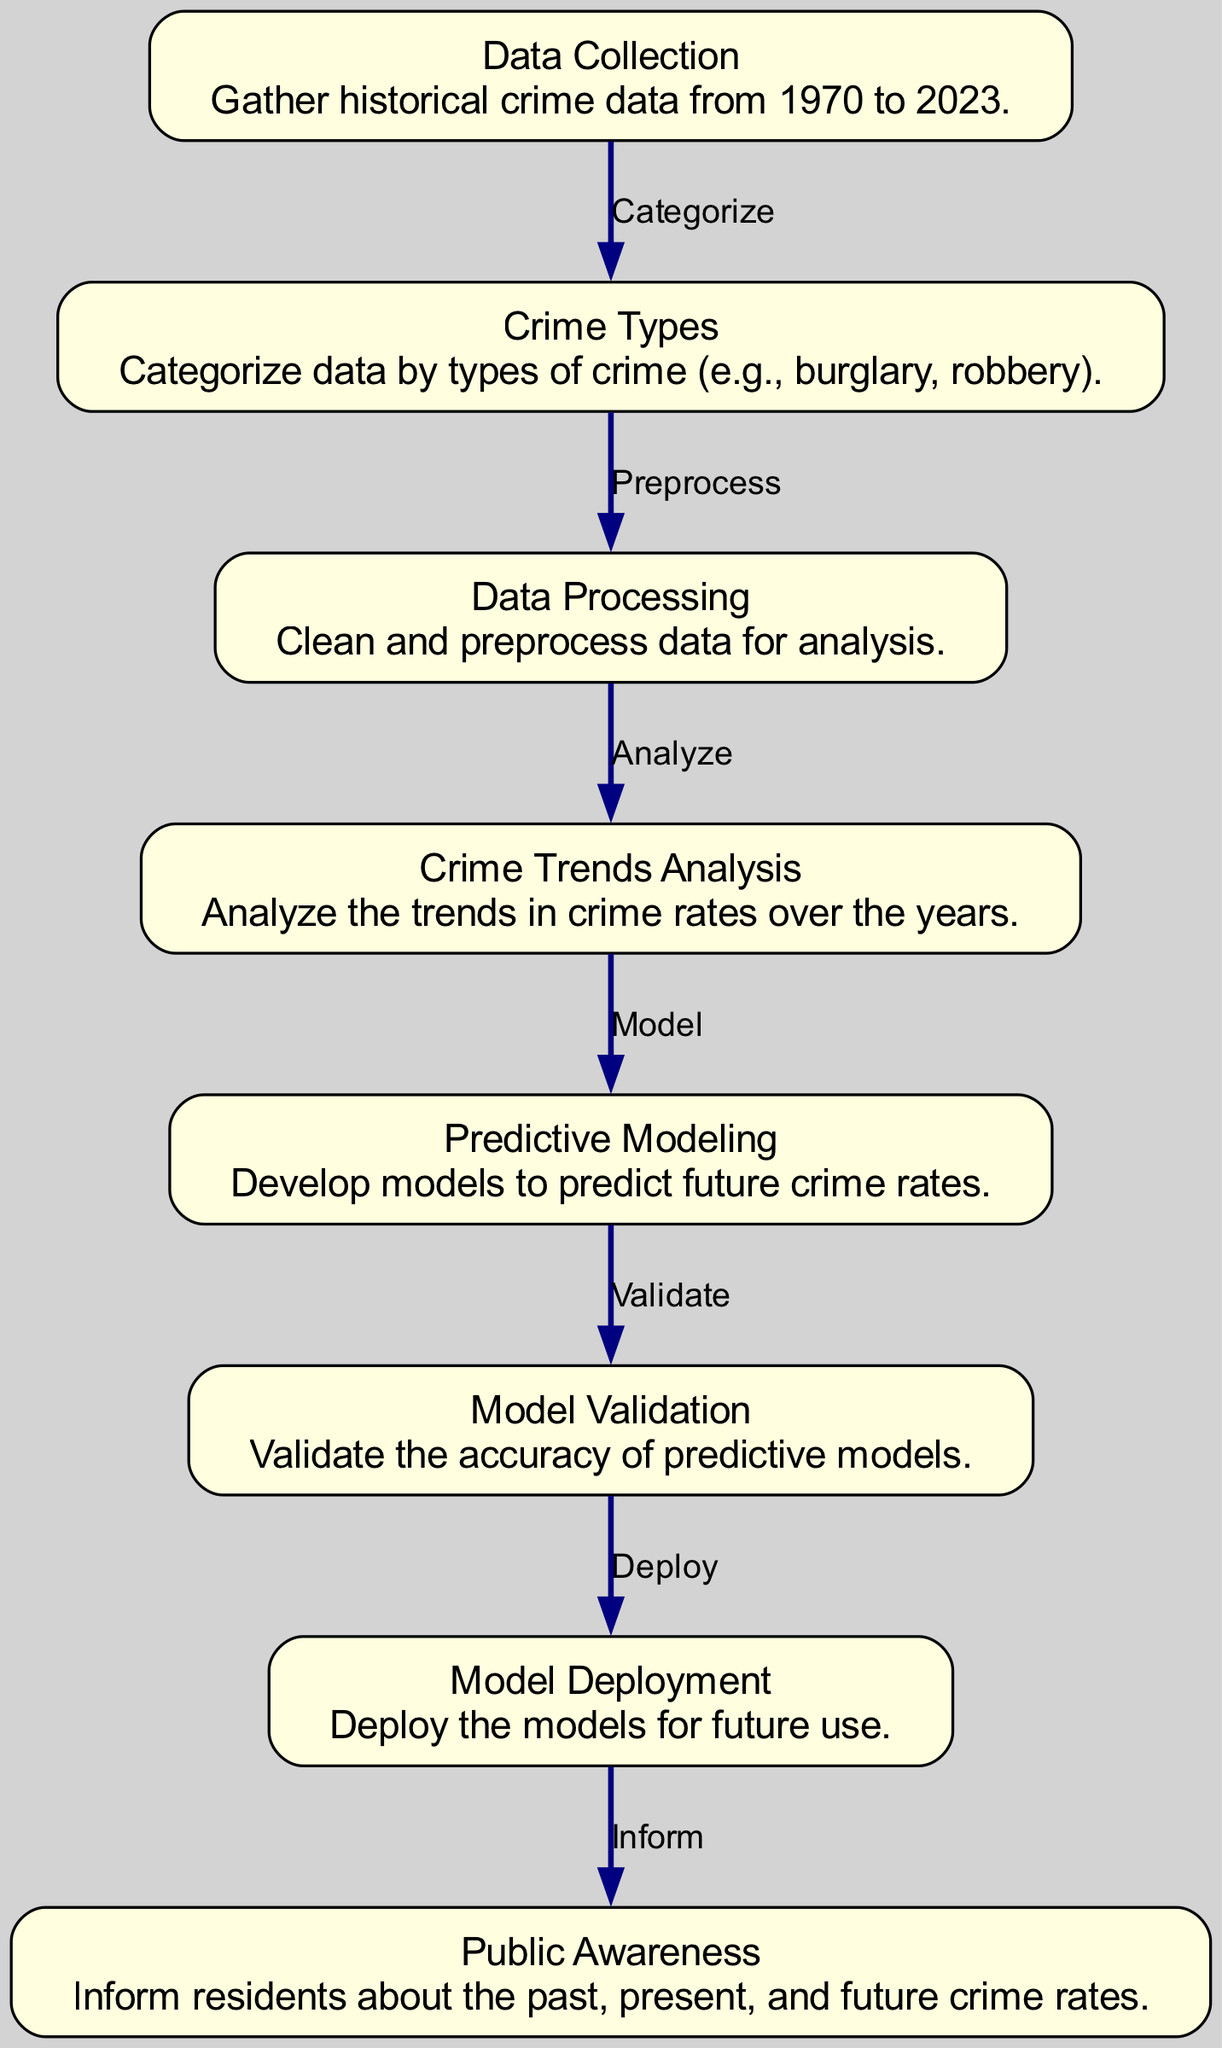What is the first node in the diagram? The first node is labeled "Data Collection", which represents the initial step in the process of analyzing crime rate trends.
Answer: Data Collection How many total nodes are in the diagram? By counting all the unique nodes presented in the diagram, there are eight nodes listed.
Answer: Eight What type of analysis is performed after the data processing? The node following "Data Processing" is "Crime Trends Analysis", indicating that the next step involves analyzing crime rate trends.
Answer: Crime Trends Analysis Which node follows the "Predictive Modeling" node? The "Validation" node immediately follows "Predictive Modeling", indicating that the model's accuracy will be validated next.
Answer: Validation What is the relationship between "Data Collection" and "Crime Types"? The "Data Collection" node categorizes data, which directly leads to the "Crime Types" node as the subsequent step.
Answer: Categorize What is the role of the "Model Deployment" node? The "Model Deployment" node indicates that after validation, the predictive models will be deployed for application.
Answer: Deploy Which node is responsible for informing residents about crime rates? The last node is "Public Awareness", which aims to inform residents about crime rates over different time periods.
Answer: Public Awareness What are the two main steps after analyzing crime trends? After "Crime Trends Analysis", the next two steps are "Predictive Modeling" and "Validation", which respectively involve creating predictive models and validating them.
Answer: Predictive Modeling and Validation How do "Crime Trends Analysis" and "Public Awareness" connect in the diagram? The connection shows that analysis of trends leads to informing the public, indicating a flow of information based on the analysis conducted.
Answer: Inform 